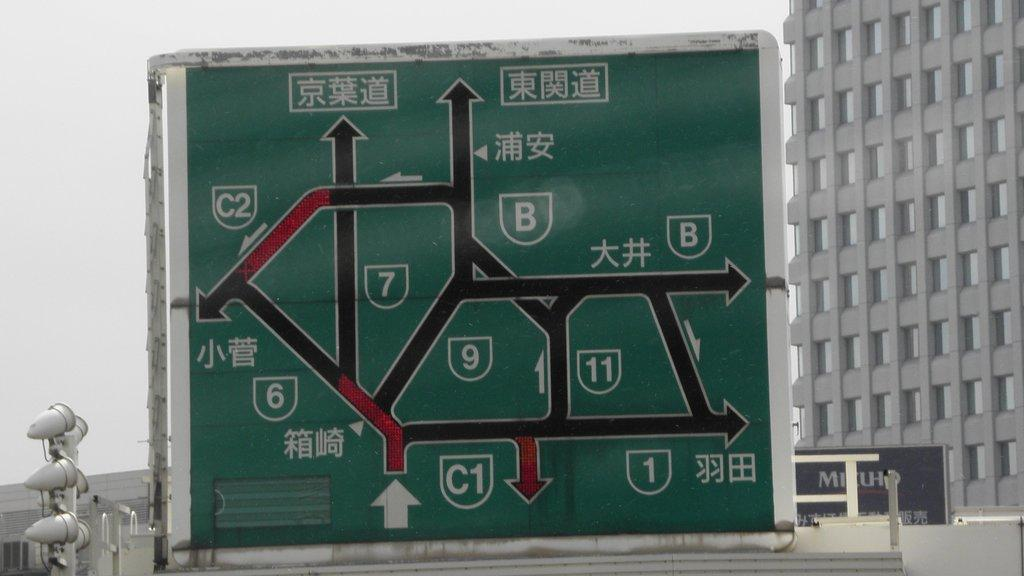<image>
Give a short and clear explanation of the subsequent image. A green colored roadway map with Asian writing on it as well as English numbers and letters. 